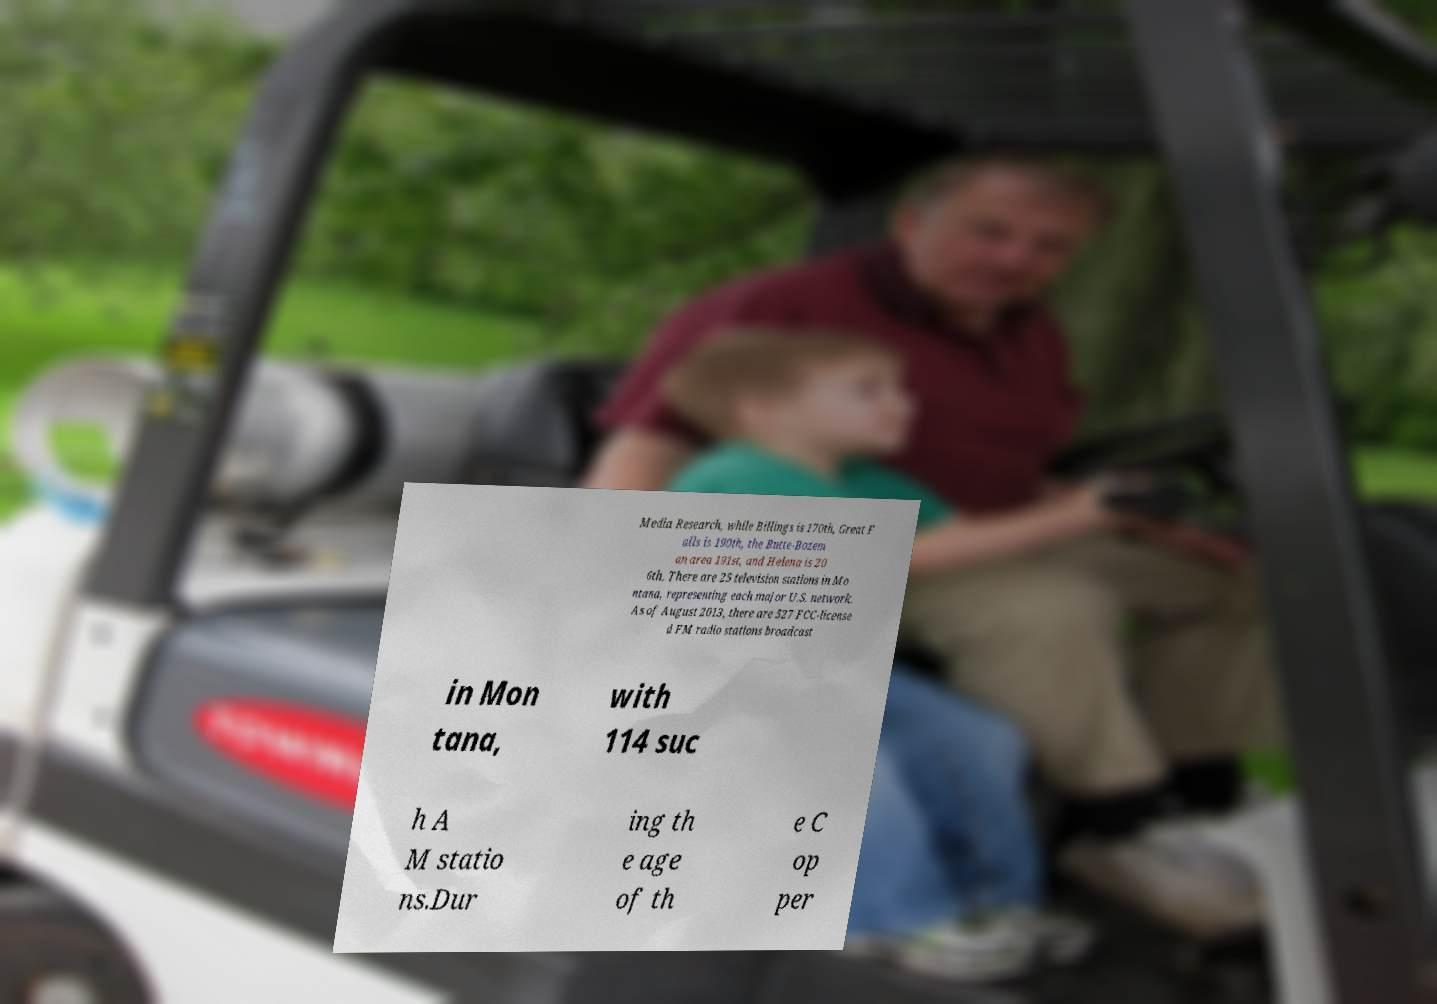Please read and relay the text visible in this image. What does it say? Media Research, while Billings is 170th, Great F alls is 190th, the Butte-Bozem an area 191st, and Helena is 20 6th. There are 25 television stations in Mo ntana, representing each major U.S. network. As of August 2013, there are 527 FCC-license d FM radio stations broadcast in Mon tana, with 114 suc h A M statio ns.Dur ing th e age of th e C op per 